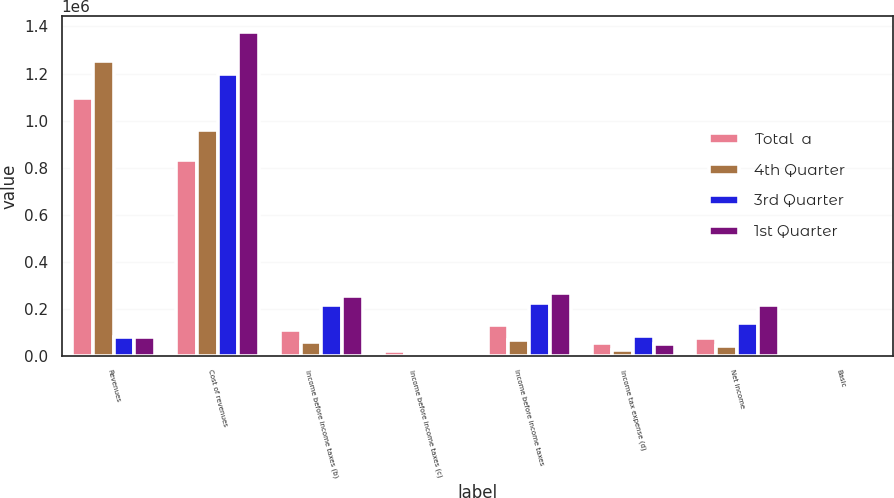<chart> <loc_0><loc_0><loc_500><loc_500><stacked_bar_chart><ecel><fcel>Revenues<fcel>Cost of revenues<fcel>Income before income taxes (b)<fcel>Income before income taxes (c)<fcel>Income before income taxes<fcel>Income tax expense (d)<fcel>Net income<fcel>Basic<nl><fcel>Total  a<fcel>1.094e+06<fcel>833614<fcel>108435<fcel>21594<fcel>130029<fcel>55210<fcel>74819<fcel>0.19<nl><fcel>4th Quarter<fcel>1.25499e+06<fcel>959524<fcel>58573<fcel>9108<fcel>67681<fcel>25801<fcel>41880<fcel>0.11<nl><fcel>3rd Quarter<fcel>79601<fcel>1.19891e+06<fcel>214051<fcel>10877<fcel>224928<fcel>84383<fcel>140545<fcel>0.37<nl><fcel>1st Quarter<fcel>79601<fcel>1.37495e+06<fcel>254118<fcel>13002<fcel>267120<fcel>50025<fcel>217095<fcel>0.58<nl></chart> 